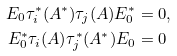Convert formula to latex. <formula><loc_0><loc_0><loc_500><loc_500>E _ { 0 } \tau ^ { * } _ { i } ( A ^ { * } ) \tau _ { j } ( A ) E ^ { * } _ { 0 } & = 0 , \\ E ^ { * } _ { 0 } \tau _ { i } ( A ) \tau ^ { * } _ { j } ( A ^ { * } ) E _ { 0 } & = 0</formula> 